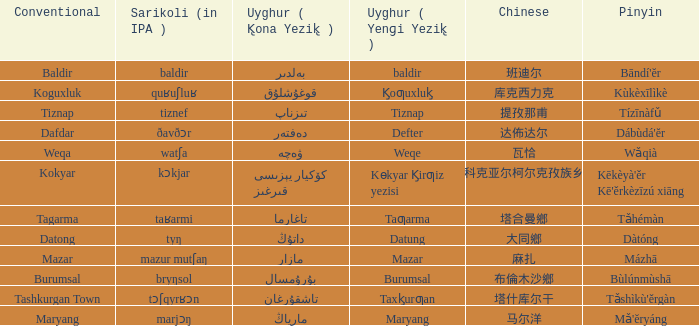Name the conventional for تاغارما Tagarma. 